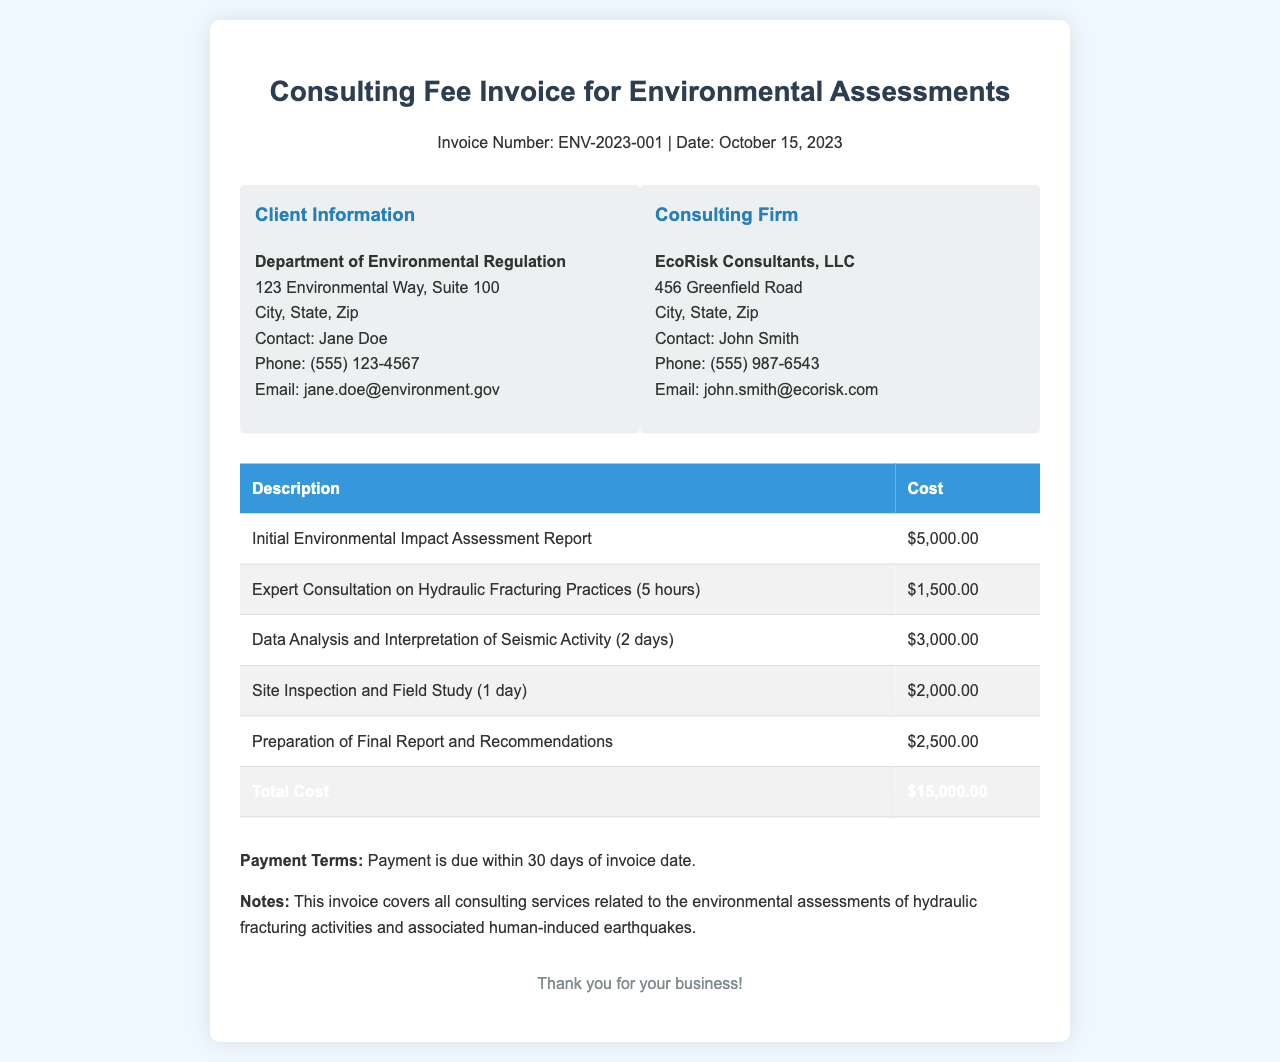What is the invoice number? The invoice number is stated in the header of the document as a unique identifier for this specific invoice.
Answer: ENV-2023-001 What is the date of the invoice? The date refers to when the invoice was issued and is found in the header section.
Answer: October 15, 2023 What is the total cost listed in the invoice? The total cost is presented at the bottom of the cost table and totals all charges for services rendered.
Answer: $15,000.00 Who is the contact person for the consulting firm? The contact person's name for EcoRisk Consultants, LLC is given in the consulting firm information box.
Answer: John Smith How much was charged for the Initial Environmental Impact Assessment Report? This specific service cost is detailed in the itemized list of services in the table.
Answer: $5,000.00 What payment terms are mentioned in the invoice? Payment terms dictate when payment is expected and are specified in the invoice text.
Answer: Payment is due within 30 days of invoice date What type of assessment does this invoice cover? The notes specify the focus of the assessment services related to environmental impact.
Answer: Environmental assessments of hydraulic fracturing activities How many hours were billed for expert consultation on hydraulic fracturing practices? The duration of consultation is mentioned in parentheses next to the service description in the table.
Answer: 5 hours 